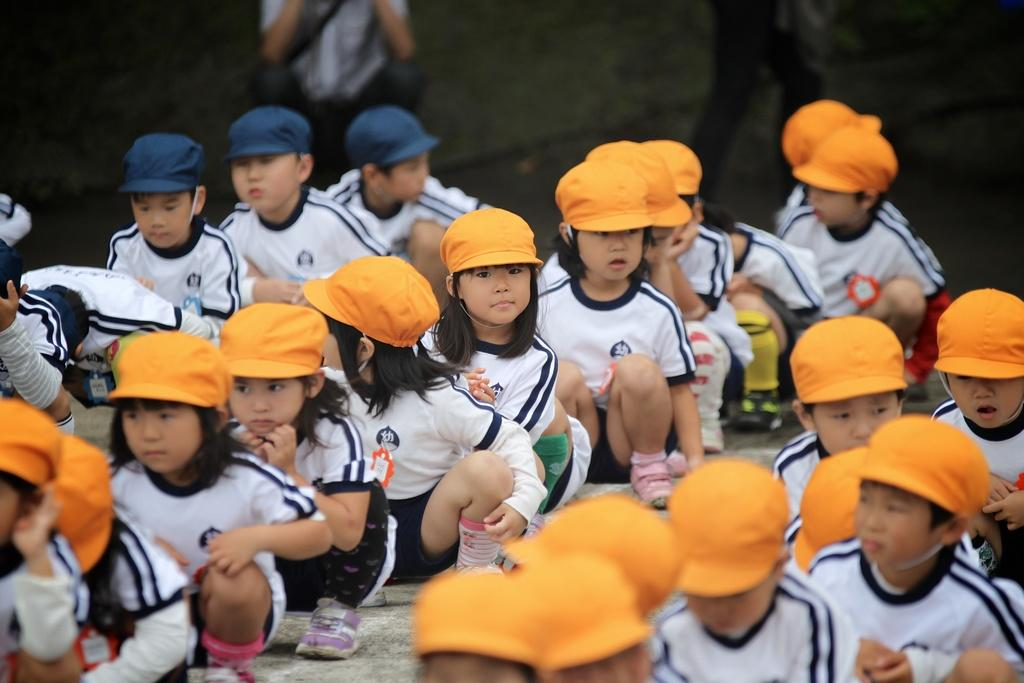What is the main subject of the image? The main subject of the image is a group of children. What are the children wearing on their heads? The children are wearing caps. Where are the children standing? The children are standing on the ground. Can you describe the background of the image? There are people visible in the background of the image. What type of cork can be seen floating in the water near the children? There is no water or cork present in the image; it features a group of children standing on the ground. 